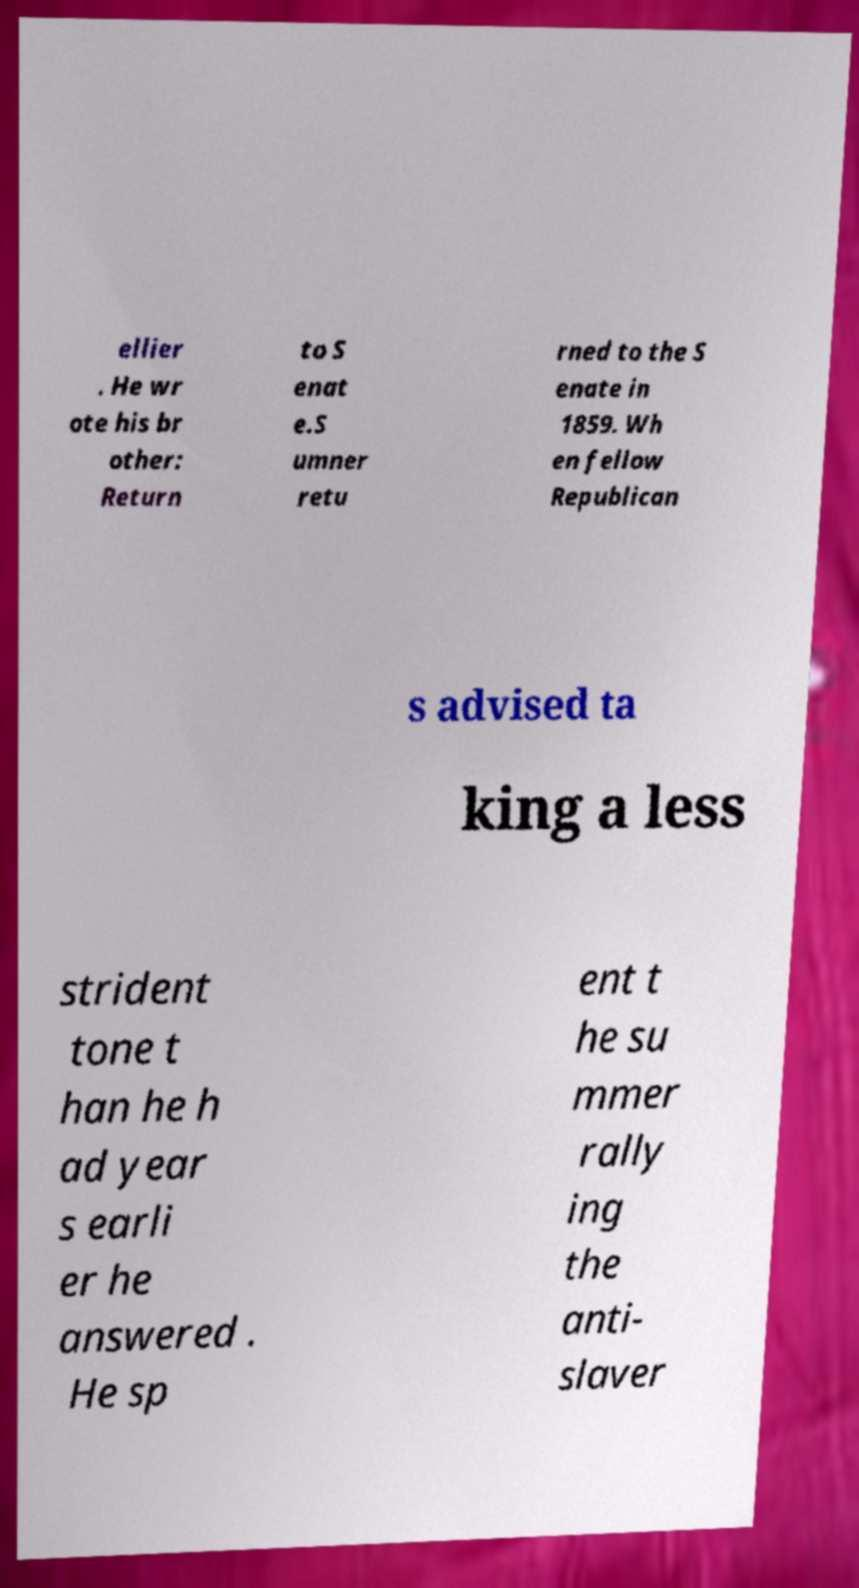Can you read and provide the text displayed in the image?This photo seems to have some interesting text. Can you extract and type it out for me? ellier . He wr ote his br other: Return to S enat e.S umner retu rned to the S enate in 1859. Wh en fellow Republican s advised ta king a less strident tone t han he h ad year s earli er he answered . He sp ent t he su mmer rally ing the anti- slaver 